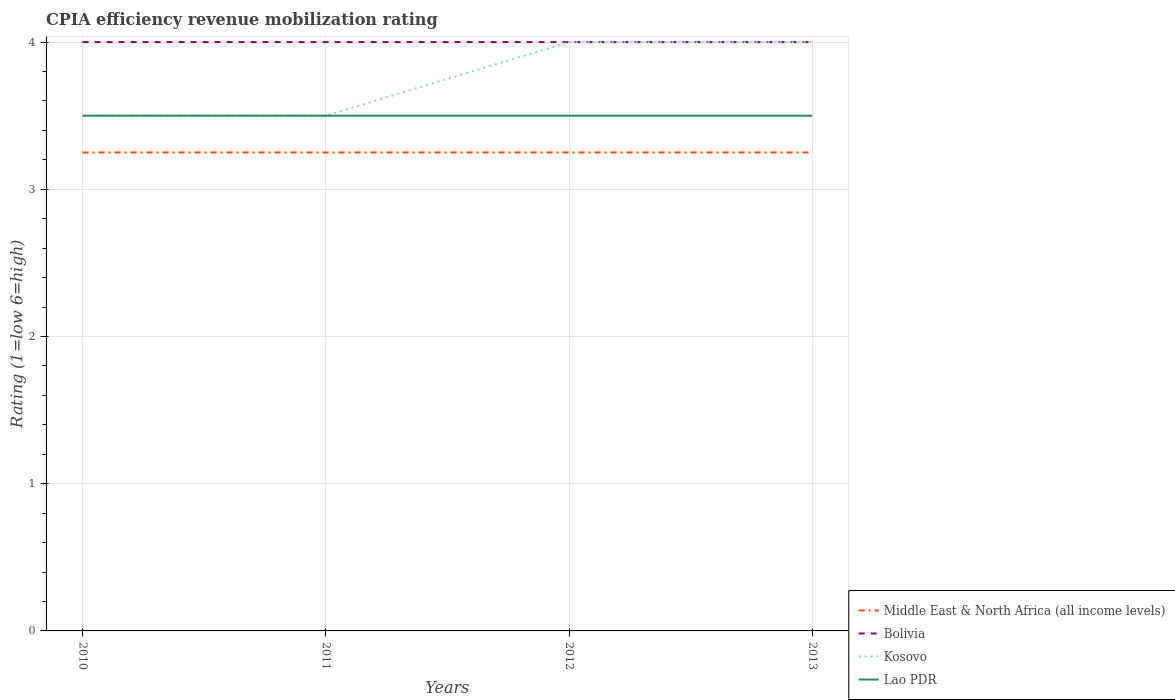Does the line corresponding to Middle East & North Africa (all income levels) intersect with the line corresponding to Bolivia?
Provide a short and direct response. No. Is the number of lines equal to the number of legend labels?
Keep it short and to the point. Yes. Across all years, what is the maximum CPIA rating in Bolivia?
Make the answer very short. 4. What is the total CPIA rating in Kosovo in the graph?
Your answer should be compact. 0. What is the difference between the highest and the lowest CPIA rating in Lao PDR?
Offer a terse response. 0. How many lines are there?
Offer a very short reply. 4. How many years are there in the graph?
Offer a very short reply. 4. What is the difference between two consecutive major ticks on the Y-axis?
Keep it short and to the point. 1. Are the values on the major ticks of Y-axis written in scientific E-notation?
Provide a short and direct response. No. Does the graph contain any zero values?
Your answer should be very brief. No. Where does the legend appear in the graph?
Your answer should be very brief. Bottom right. What is the title of the graph?
Ensure brevity in your answer.  CPIA efficiency revenue mobilization rating. What is the label or title of the X-axis?
Offer a terse response. Years. What is the Rating (1=low 6=high) in Kosovo in 2010?
Ensure brevity in your answer.  3.5. What is the Rating (1=low 6=high) of Middle East & North Africa (all income levels) in 2011?
Provide a short and direct response. 3.25. What is the Rating (1=low 6=high) of Bolivia in 2011?
Keep it short and to the point. 4. What is the Rating (1=low 6=high) of Lao PDR in 2012?
Give a very brief answer. 3.5. What is the Rating (1=low 6=high) of Kosovo in 2013?
Give a very brief answer. 4. What is the Rating (1=low 6=high) in Lao PDR in 2013?
Your answer should be compact. 3.5. Across all years, what is the maximum Rating (1=low 6=high) in Middle East & North Africa (all income levels)?
Make the answer very short. 3.25. Across all years, what is the maximum Rating (1=low 6=high) of Bolivia?
Give a very brief answer. 4. Across all years, what is the maximum Rating (1=low 6=high) in Lao PDR?
Provide a succinct answer. 3.5. Across all years, what is the minimum Rating (1=low 6=high) of Middle East & North Africa (all income levels)?
Your answer should be very brief. 3.25. Across all years, what is the minimum Rating (1=low 6=high) of Bolivia?
Give a very brief answer. 4. Across all years, what is the minimum Rating (1=low 6=high) of Lao PDR?
Provide a succinct answer. 3.5. What is the total Rating (1=low 6=high) in Bolivia in the graph?
Make the answer very short. 16. What is the total Rating (1=low 6=high) of Kosovo in the graph?
Provide a succinct answer. 15. What is the difference between the Rating (1=low 6=high) in Middle East & North Africa (all income levels) in 2010 and that in 2011?
Your response must be concise. 0. What is the difference between the Rating (1=low 6=high) in Bolivia in 2010 and that in 2012?
Ensure brevity in your answer.  0. What is the difference between the Rating (1=low 6=high) in Middle East & North Africa (all income levels) in 2010 and that in 2013?
Offer a very short reply. 0. What is the difference between the Rating (1=low 6=high) in Bolivia in 2010 and that in 2013?
Give a very brief answer. 0. What is the difference between the Rating (1=low 6=high) of Middle East & North Africa (all income levels) in 2011 and that in 2012?
Your answer should be compact. 0. What is the difference between the Rating (1=low 6=high) in Kosovo in 2011 and that in 2012?
Give a very brief answer. -0.5. What is the difference between the Rating (1=low 6=high) in Middle East & North Africa (all income levels) in 2011 and that in 2013?
Provide a short and direct response. 0. What is the difference between the Rating (1=low 6=high) of Bolivia in 2011 and that in 2013?
Your response must be concise. 0. What is the difference between the Rating (1=low 6=high) of Kosovo in 2011 and that in 2013?
Keep it short and to the point. -0.5. What is the difference between the Rating (1=low 6=high) in Lao PDR in 2011 and that in 2013?
Ensure brevity in your answer.  0. What is the difference between the Rating (1=low 6=high) of Bolivia in 2012 and that in 2013?
Give a very brief answer. 0. What is the difference between the Rating (1=low 6=high) in Middle East & North Africa (all income levels) in 2010 and the Rating (1=low 6=high) in Bolivia in 2011?
Ensure brevity in your answer.  -0.75. What is the difference between the Rating (1=low 6=high) of Middle East & North Africa (all income levels) in 2010 and the Rating (1=low 6=high) of Lao PDR in 2011?
Provide a succinct answer. -0.25. What is the difference between the Rating (1=low 6=high) of Kosovo in 2010 and the Rating (1=low 6=high) of Lao PDR in 2011?
Provide a succinct answer. 0. What is the difference between the Rating (1=low 6=high) of Middle East & North Africa (all income levels) in 2010 and the Rating (1=low 6=high) of Bolivia in 2012?
Your response must be concise. -0.75. What is the difference between the Rating (1=low 6=high) of Middle East & North Africa (all income levels) in 2010 and the Rating (1=low 6=high) of Kosovo in 2012?
Provide a short and direct response. -0.75. What is the difference between the Rating (1=low 6=high) in Bolivia in 2010 and the Rating (1=low 6=high) in Lao PDR in 2012?
Keep it short and to the point. 0.5. What is the difference between the Rating (1=low 6=high) in Kosovo in 2010 and the Rating (1=low 6=high) in Lao PDR in 2012?
Your answer should be compact. 0. What is the difference between the Rating (1=low 6=high) of Middle East & North Africa (all income levels) in 2010 and the Rating (1=low 6=high) of Bolivia in 2013?
Give a very brief answer. -0.75. What is the difference between the Rating (1=low 6=high) of Middle East & North Africa (all income levels) in 2010 and the Rating (1=low 6=high) of Kosovo in 2013?
Provide a succinct answer. -0.75. What is the difference between the Rating (1=low 6=high) in Bolivia in 2010 and the Rating (1=low 6=high) in Lao PDR in 2013?
Your answer should be very brief. 0.5. What is the difference between the Rating (1=low 6=high) of Kosovo in 2010 and the Rating (1=low 6=high) of Lao PDR in 2013?
Ensure brevity in your answer.  0. What is the difference between the Rating (1=low 6=high) in Middle East & North Africa (all income levels) in 2011 and the Rating (1=low 6=high) in Bolivia in 2012?
Give a very brief answer. -0.75. What is the difference between the Rating (1=low 6=high) in Middle East & North Africa (all income levels) in 2011 and the Rating (1=low 6=high) in Kosovo in 2012?
Keep it short and to the point. -0.75. What is the difference between the Rating (1=low 6=high) in Bolivia in 2011 and the Rating (1=low 6=high) in Kosovo in 2012?
Provide a short and direct response. 0. What is the difference between the Rating (1=low 6=high) of Kosovo in 2011 and the Rating (1=low 6=high) of Lao PDR in 2012?
Make the answer very short. 0. What is the difference between the Rating (1=low 6=high) of Middle East & North Africa (all income levels) in 2011 and the Rating (1=low 6=high) of Bolivia in 2013?
Offer a terse response. -0.75. What is the difference between the Rating (1=low 6=high) of Middle East & North Africa (all income levels) in 2011 and the Rating (1=low 6=high) of Kosovo in 2013?
Give a very brief answer. -0.75. What is the difference between the Rating (1=low 6=high) in Bolivia in 2011 and the Rating (1=low 6=high) in Kosovo in 2013?
Ensure brevity in your answer.  0. What is the difference between the Rating (1=low 6=high) in Bolivia in 2011 and the Rating (1=low 6=high) in Lao PDR in 2013?
Offer a very short reply. 0.5. What is the difference between the Rating (1=low 6=high) of Kosovo in 2011 and the Rating (1=low 6=high) of Lao PDR in 2013?
Your answer should be compact. 0. What is the difference between the Rating (1=low 6=high) of Middle East & North Africa (all income levels) in 2012 and the Rating (1=low 6=high) of Bolivia in 2013?
Make the answer very short. -0.75. What is the difference between the Rating (1=low 6=high) of Middle East & North Africa (all income levels) in 2012 and the Rating (1=low 6=high) of Kosovo in 2013?
Provide a short and direct response. -0.75. What is the difference between the Rating (1=low 6=high) in Middle East & North Africa (all income levels) in 2012 and the Rating (1=low 6=high) in Lao PDR in 2013?
Make the answer very short. -0.25. What is the difference between the Rating (1=low 6=high) of Bolivia in 2012 and the Rating (1=low 6=high) of Kosovo in 2013?
Provide a short and direct response. 0. What is the difference between the Rating (1=low 6=high) of Bolivia in 2012 and the Rating (1=low 6=high) of Lao PDR in 2013?
Give a very brief answer. 0.5. What is the difference between the Rating (1=low 6=high) of Kosovo in 2012 and the Rating (1=low 6=high) of Lao PDR in 2013?
Offer a terse response. 0.5. What is the average Rating (1=low 6=high) in Bolivia per year?
Your answer should be very brief. 4. What is the average Rating (1=low 6=high) of Kosovo per year?
Offer a very short reply. 3.75. What is the average Rating (1=low 6=high) of Lao PDR per year?
Your response must be concise. 3.5. In the year 2010, what is the difference between the Rating (1=low 6=high) in Middle East & North Africa (all income levels) and Rating (1=low 6=high) in Bolivia?
Your answer should be compact. -0.75. In the year 2010, what is the difference between the Rating (1=low 6=high) in Middle East & North Africa (all income levels) and Rating (1=low 6=high) in Kosovo?
Ensure brevity in your answer.  -0.25. In the year 2010, what is the difference between the Rating (1=low 6=high) of Middle East & North Africa (all income levels) and Rating (1=low 6=high) of Lao PDR?
Offer a terse response. -0.25. In the year 2010, what is the difference between the Rating (1=low 6=high) of Bolivia and Rating (1=low 6=high) of Kosovo?
Provide a short and direct response. 0.5. In the year 2011, what is the difference between the Rating (1=low 6=high) of Middle East & North Africa (all income levels) and Rating (1=low 6=high) of Bolivia?
Give a very brief answer. -0.75. In the year 2011, what is the difference between the Rating (1=low 6=high) of Middle East & North Africa (all income levels) and Rating (1=low 6=high) of Kosovo?
Keep it short and to the point. -0.25. In the year 2011, what is the difference between the Rating (1=low 6=high) in Bolivia and Rating (1=low 6=high) in Kosovo?
Your response must be concise. 0.5. In the year 2011, what is the difference between the Rating (1=low 6=high) of Bolivia and Rating (1=low 6=high) of Lao PDR?
Offer a terse response. 0.5. In the year 2012, what is the difference between the Rating (1=low 6=high) in Middle East & North Africa (all income levels) and Rating (1=low 6=high) in Bolivia?
Your answer should be compact. -0.75. In the year 2012, what is the difference between the Rating (1=low 6=high) of Middle East & North Africa (all income levels) and Rating (1=low 6=high) of Kosovo?
Offer a very short reply. -0.75. In the year 2012, what is the difference between the Rating (1=low 6=high) of Bolivia and Rating (1=low 6=high) of Kosovo?
Offer a very short reply. 0. In the year 2013, what is the difference between the Rating (1=low 6=high) of Middle East & North Africa (all income levels) and Rating (1=low 6=high) of Bolivia?
Offer a terse response. -0.75. In the year 2013, what is the difference between the Rating (1=low 6=high) of Middle East & North Africa (all income levels) and Rating (1=low 6=high) of Kosovo?
Your answer should be very brief. -0.75. In the year 2013, what is the difference between the Rating (1=low 6=high) of Middle East & North Africa (all income levels) and Rating (1=low 6=high) of Lao PDR?
Provide a short and direct response. -0.25. What is the ratio of the Rating (1=low 6=high) in Bolivia in 2010 to that in 2011?
Provide a succinct answer. 1. What is the ratio of the Rating (1=low 6=high) of Lao PDR in 2010 to that in 2011?
Your answer should be very brief. 1. What is the ratio of the Rating (1=low 6=high) in Bolivia in 2010 to that in 2012?
Make the answer very short. 1. What is the ratio of the Rating (1=low 6=high) in Lao PDR in 2010 to that in 2012?
Your response must be concise. 1. What is the ratio of the Rating (1=low 6=high) in Bolivia in 2010 to that in 2013?
Offer a very short reply. 1. What is the ratio of the Rating (1=low 6=high) in Lao PDR in 2010 to that in 2013?
Provide a succinct answer. 1. What is the ratio of the Rating (1=low 6=high) in Middle East & North Africa (all income levels) in 2011 to that in 2012?
Ensure brevity in your answer.  1. What is the ratio of the Rating (1=low 6=high) in Lao PDR in 2011 to that in 2012?
Ensure brevity in your answer.  1. What is the ratio of the Rating (1=low 6=high) in Middle East & North Africa (all income levels) in 2011 to that in 2013?
Provide a short and direct response. 1. What is the ratio of the Rating (1=low 6=high) of Bolivia in 2011 to that in 2013?
Offer a very short reply. 1. What is the ratio of the Rating (1=low 6=high) of Kosovo in 2011 to that in 2013?
Your answer should be very brief. 0.88. What is the ratio of the Rating (1=low 6=high) in Kosovo in 2012 to that in 2013?
Ensure brevity in your answer.  1. What is the difference between the highest and the second highest Rating (1=low 6=high) in Middle East & North Africa (all income levels)?
Your answer should be compact. 0. What is the difference between the highest and the second highest Rating (1=low 6=high) in Bolivia?
Ensure brevity in your answer.  0. What is the difference between the highest and the second highest Rating (1=low 6=high) of Kosovo?
Give a very brief answer. 0. What is the difference between the highest and the second highest Rating (1=low 6=high) of Lao PDR?
Provide a succinct answer. 0. What is the difference between the highest and the lowest Rating (1=low 6=high) in Middle East & North Africa (all income levels)?
Your answer should be very brief. 0. 